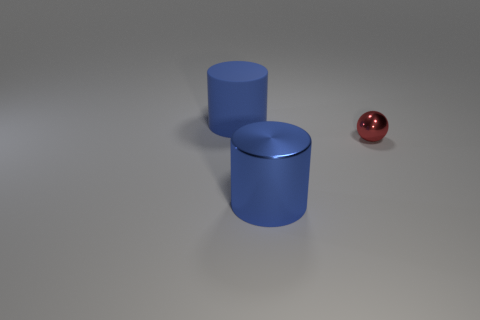Are there an equal number of metal cylinders that are to the right of the red metal thing and big blue objects that are behind the large blue metallic cylinder?
Provide a short and direct response. No. There is a large object to the right of the large blue cylinder on the left side of the blue cylinder that is on the right side of the large blue matte thing; what shape is it?
Your response must be concise. Cylinder. Is the thing left of the blue shiny thing made of the same material as the large object that is in front of the ball?
Your answer should be very brief. No. The matte object that is behind the red ball has what shape?
Offer a very short reply. Cylinder. Is the number of green objects less than the number of blue cylinders?
Make the answer very short. Yes. Is there a ball that is to the left of the cylinder that is left of the metal object in front of the metallic ball?
Make the answer very short. No. How many metallic things are tiny red things or green objects?
Your answer should be compact. 1. Is the small shiny thing the same color as the big matte object?
Your response must be concise. No. There is a big blue shiny object; what number of metal cylinders are behind it?
Make the answer very short. 0. How many things are in front of the small red shiny sphere and behind the red shiny object?
Keep it short and to the point. 0. 